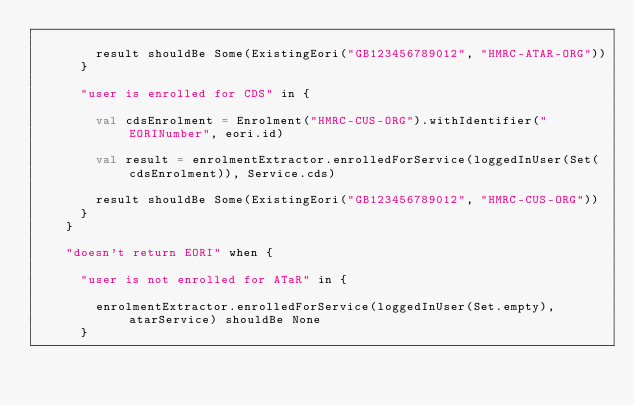Convert code to text. <code><loc_0><loc_0><loc_500><loc_500><_Scala_>
        result shouldBe Some(ExistingEori("GB123456789012", "HMRC-ATAR-ORG"))
      }

      "user is enrolled for CDS" in {

        val cdsEnrolment = Enrolment("HMRC-CUS-ORG").withIdentifier("EORINumber", eori.id)

        val result = enrolmentExtractor.enrolledForService(loggedInUser(Set(cdsEnrolment)), Service.cds)

        result shouldBe Some(ExistingEori("GB123456789012", "HMRC-CUS-ORG"))
      }
    }

    "doesn't return EORI" when {

      "user is not enrolled for ATaR" in {

        enrolmentExtractor.enrolledForService(loggedInUser(Set.empty), atarService) shouldBe None
      }
</code> 